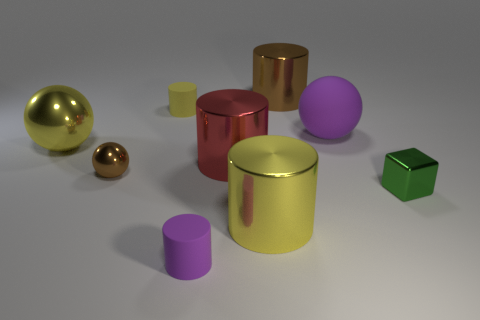What is the shape of the yellow matte object?
Your response must be concise. Cylinder. Is the tiny green cube made of the same material as the tiny purple cylinder?
Offer a terse response. No. There is a sphere that is right of the yellow cylinder in front of the yellow rubber cylinder; is there a large purple matte object to the left of it?
Your answer should be very brief. No. What number of other objects are there of the same shape as the green metal thing?
Your answer should be compact. 0. The big metal object that is behind the large red metal thing and right of the red shiny cylinder has what shape?
Your answer should be very brief. Cylinder. There is a large sphere that is to the right of the brown metal thing that is to the right of the tiny matte object behind the big red metal thing; what is its color?
Your answer should be compact. Purple. Is the number of large cylinders that are right of the large yellow ball greater than the number of large balls in front of the yellow rubber cylinder?
Your answer should be very brief. Yes. What number of other things are the same size as the purple ball?
Offer a terse response. 4. What size is the other thing that is the same color as the big matte object?
Offer a terse response. Small. There is a purple cylinder that is right of the yellow shiny thing that is left of the tiny purple thing; what is its material?
Give a very brief answer. Rubber. 